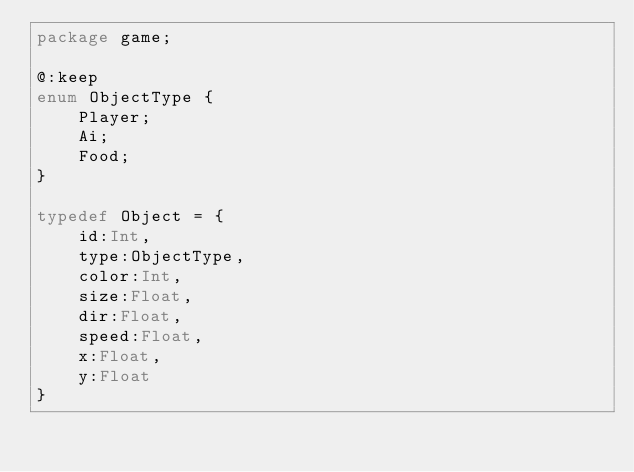<code> <loc_0><loc_0><loc_500><loc_500><_Haxe_>package game;

@:keep
enum ObjectType {
	Player;
	Ai;
	Food;
}

typedef Object = {
	id:Int,
	type:ObjectType,
	color:Int,
	size:Float,
	dir:Float,
	speed:Float,
	x:Float,
	y:Float
}</code> 